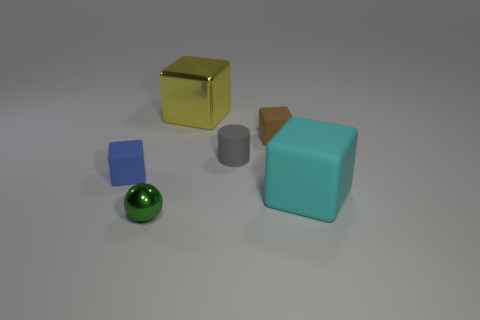How many tiny things are either green things or cyan matte blocks?
Offer a very short reply. 1. There is a brown cube; is it the same size as the metallic object that is to the left of the large yellow metallic object?
Your answer should be compact. Yes. How many other objects are the same shape as the yellow object?
Your answer should be compact. 3. What is the shape of the large cyan object that is made of the same material as the cylinder?
Your answer should be compact. Cube. Are any tiny rubber cylinders visible?
Give a very brief answer. Yes. Are there fewer small gray matte things behind the small brown block than blue things that are in front of the large cyan cube?
Your answer should be compact. No. What is the shape of the metal thing behind the tiny gray thing?
Make the answer very short. Cube. Does the tiny brown cube have the same material as the yellow object?
Provide a succinct answer. No. Is there any other thing that is the same material as the gray thing?
Make the answer very short. Yes. There is a small blue thing that is the same shape as the large cyan matte thing; what is it made of?
Your answer should be very brief. Rubber. 